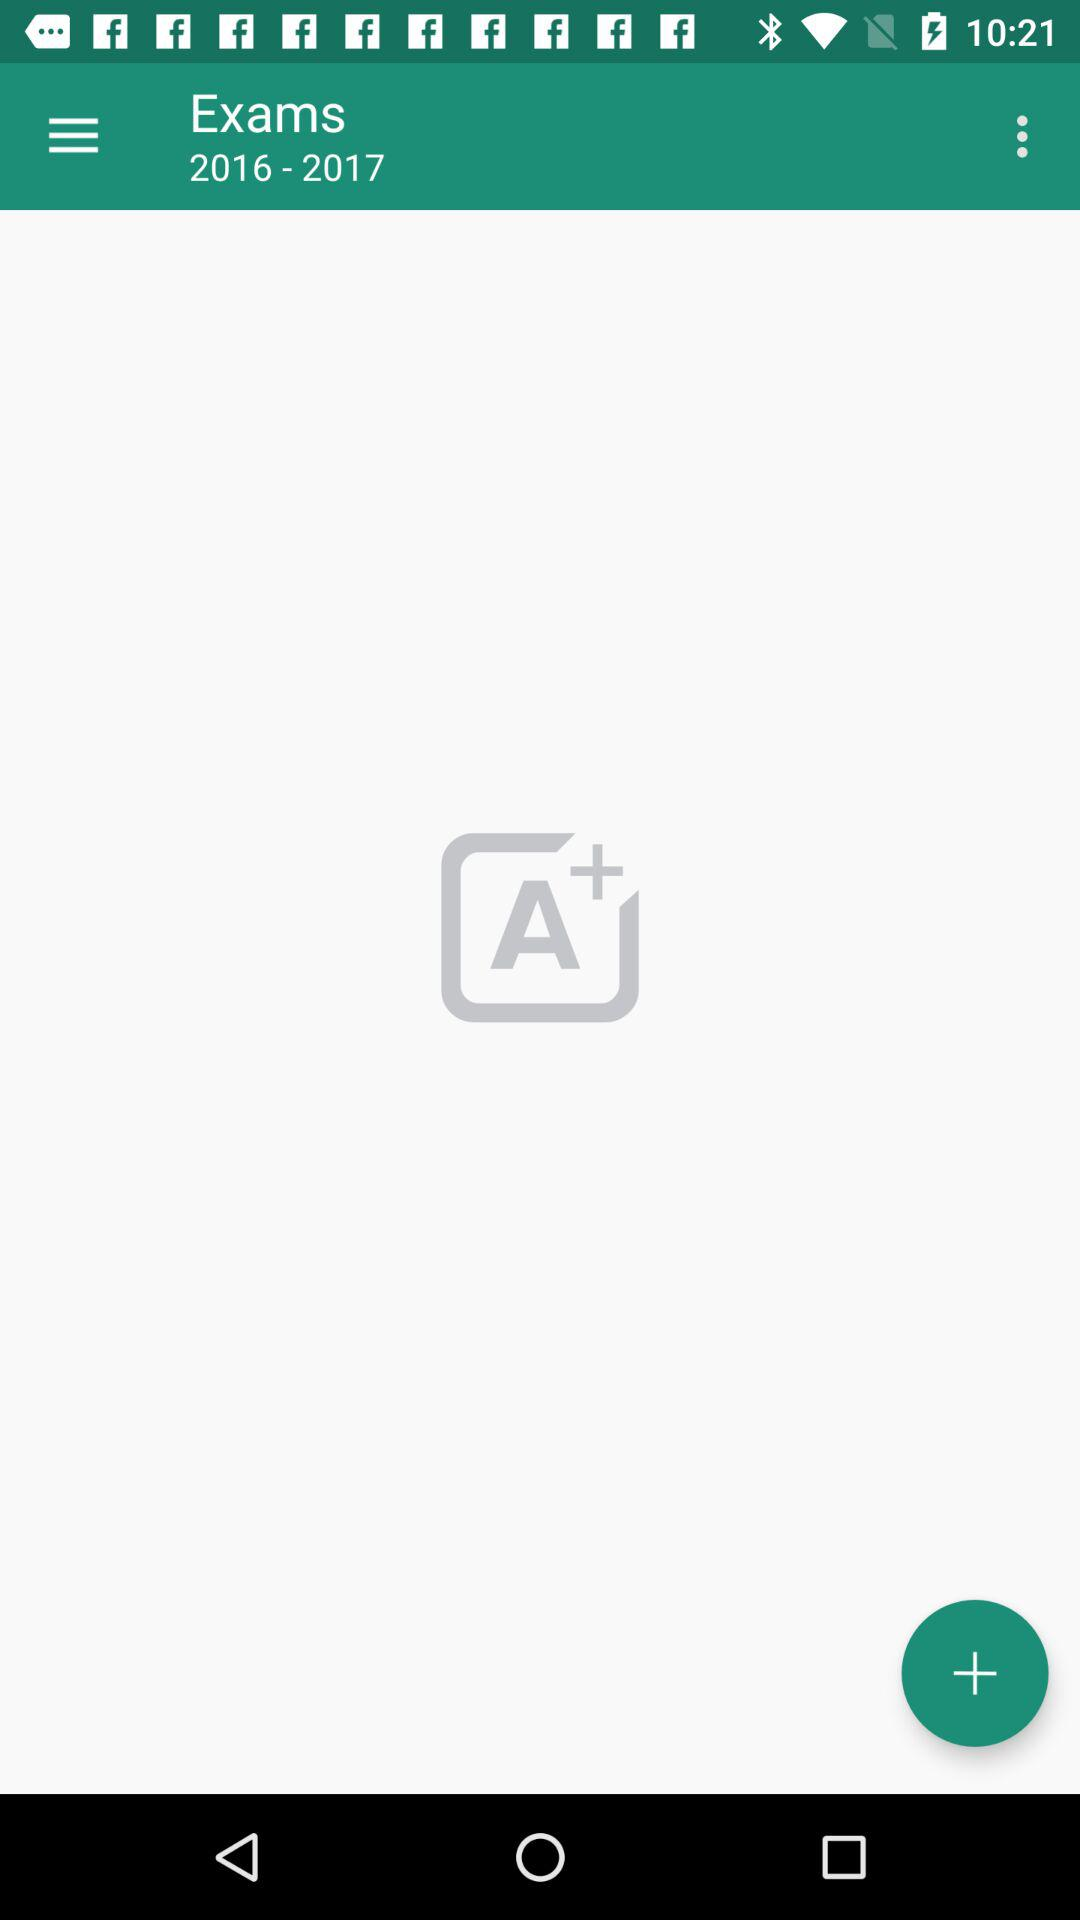What is the given exam year? The given exam year is from 2016 to 2017. 